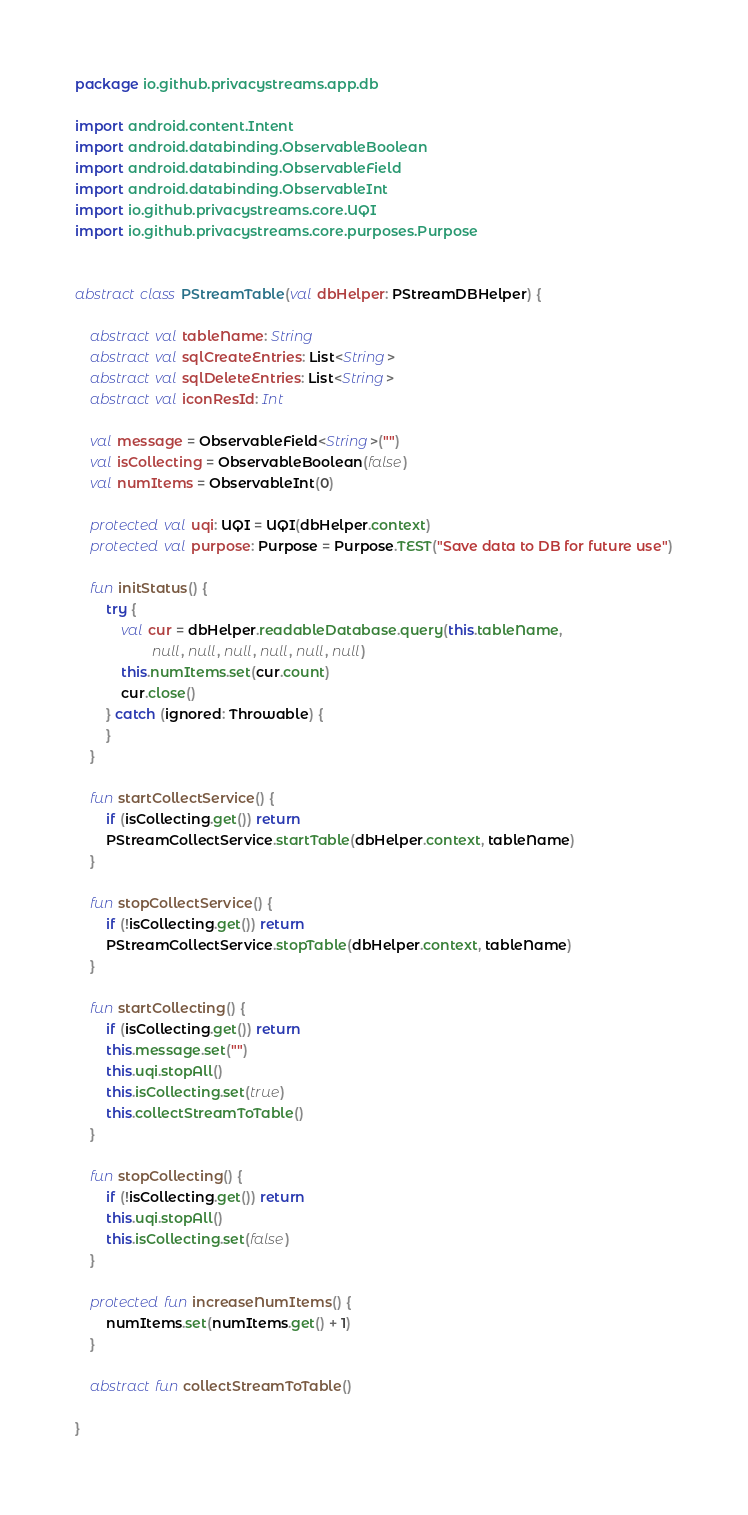<code> <loc_0><loc_0><loc_500><loc_500><_Kotlin_>package io.github.privacystreams.app.db

import android.content.Intent
import android.databinding.ObservableBoolean
import android.databinding.ObservableField
import android.databinding.ObservableInt
import io.github.privacystreams.core.UQI
import io.github.privacystreams.core.purposes.Purpose


abstract class PStreamTable(val dbHelper: PStreamDBHelper) {

    abstract val tableName: String
    abstract val sqlCreateEntries: List<String>
    abstract val sqlDeleteEntries: List<String>
    abstract val iconResId: Int

    val message = ObservableField<String>("")
    val isCollecting = ObservableBoolean(false)
    val numItems = ObservableInt(0)

    protected val uqi: UQI = UQI(dbHelper.context)
    protected val purpose: Purpose = Purpose.TEST("Save data to DB for future use")

    fun initStatus() {
        try {
            val cur = dbHelper.readableDatabase.query(this.tableName,
                    null, null, null, null, null, null)
            this.numItems.set(cur.count)
            cur.close()
        } catch (ignored: Throwable) {
        }
    }

    fun startCollectService() {
        if (isCollecting.get()) return
        PStreamCollectService.startTable(dbHelper.context, tableName)
    }

    fun stopCollectService() {
        if (!isCollecting.get()) return
        PStreamCollectService.stopTable(dbHelper.context, tableName)
    }

    fun startCollecting() {
        if (isCollecting.get()) return
        this.message.set("")
        this.uqi.stopAll()
        this.isCollecting.set(true)
        this.collectStreamToTable()
    }

    fun stopCollecting() {
        if (!isCollecting.get()) return
        this.uqi.stopAll()
        this.isCollecting.set(false)
    }

    protected fun increaseNumItems() {
        numItems.set(numItems.get() + 1)
    }

    abstract fun collectStreamToTable()

}
</code> 